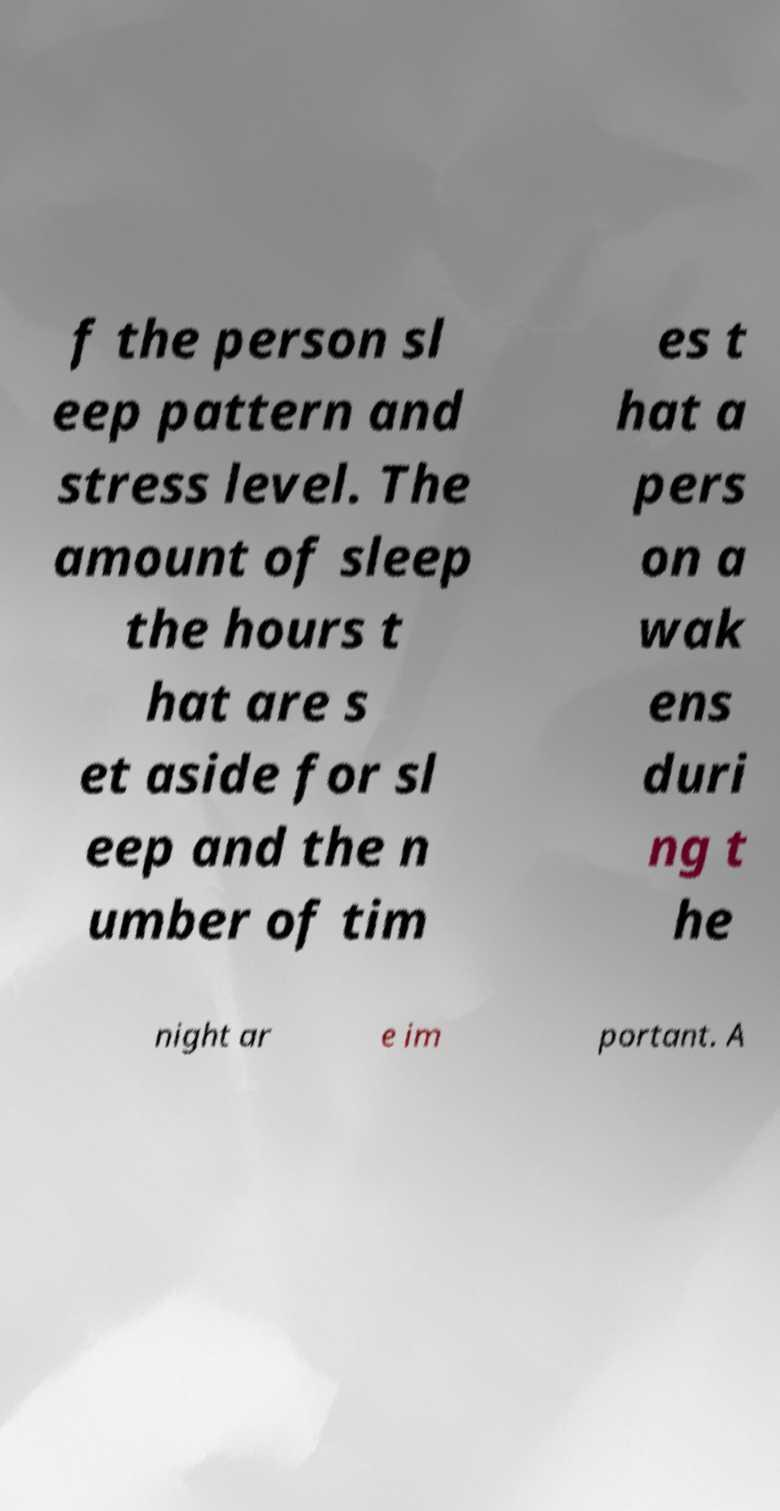There's text embedded in this image that I need extracted. Can you transcribe it verbatim? f the person sl eep pattern and stress level. The amount of sleep the hours t hat are s et aside for sl eep and the n umber of tim es t hat a pers on a wak ens duri ng t he night ar e im portant. A 